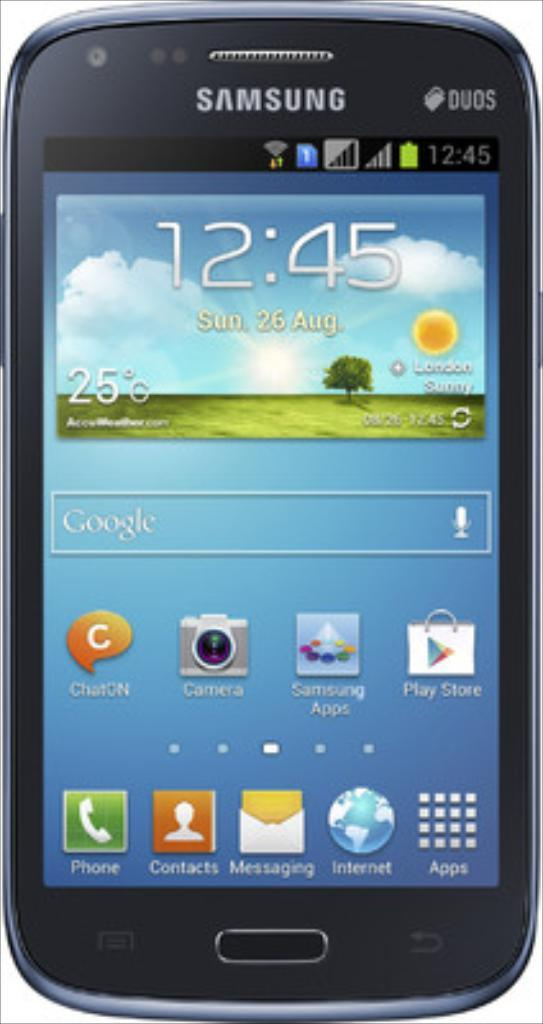<image>
Render a clear and concise summary of the photo. A small green field with one single tree and the sun is on the screen of a Samsung phone. 